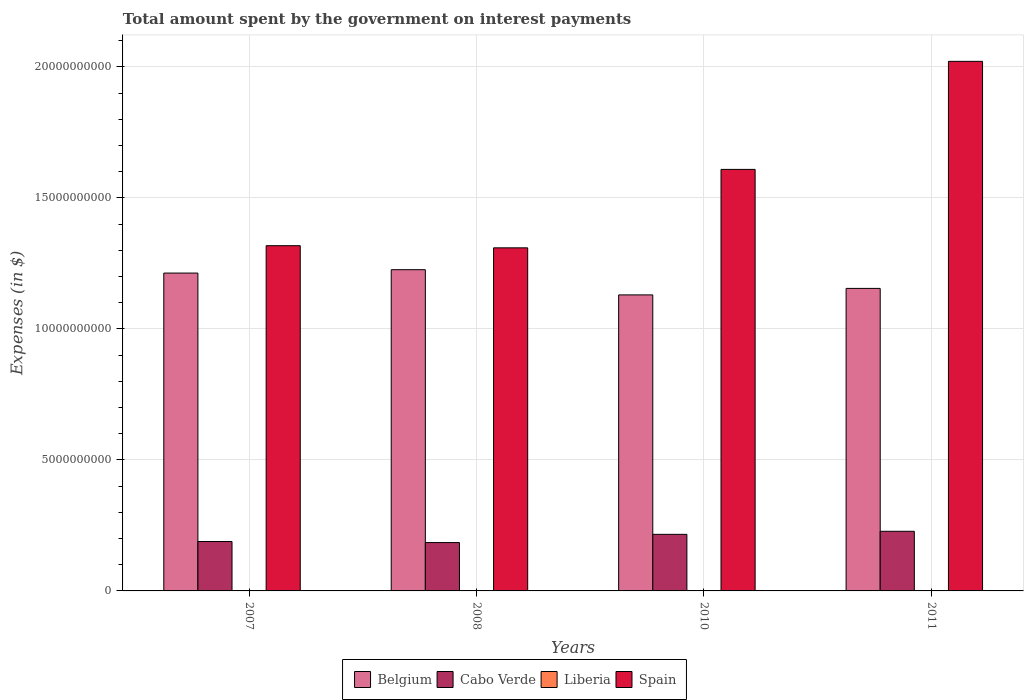Are the number of bars per tick equal to the number of legend labels?
Offer a very short reply. Yes. How many bars are there on the 4th tick from the left?
Offer a very short reply. 4. What is the label of the 3rd group of bars from the left?
Make the answer very short. 2010. What is the amount spent on interest payments by the government in Cabo Verde in 2011?
Offer a very short reply. 2.28e+09. Across all years, what is the maximum amount spent on interest payments by the government in Liberia?
Offer a terse response. 2.44e+05. Across all years, what is the minimum amount spent on interest payments by the government in Liberia?
Offer a very short reply. 2.20e+04. In which year was the amount spent on interest payments by the government in Liberia maximum?
Give a very brief answer. 2011. What is the total amount spent on interest payments by the government in Cabo Verde in the graph?
Provide a succinct answer. 8.17e+09. What is the difference between the amount spent on interest payments by the government in Belgium in 2007 and that in 2011?
Your response must be concise. 5.85e+08. What is the difference between the amount spent on interest payments by the government in Spain in 2007 and the amount spent on interest payments by the government in Belgium in 2010?
Your answer should be very brief. 1.88e+09. What is the average amount spent on interest payments by the government in Liberia per year?
Make the answer very short. 1.31e+05. In the year 2011, what is the difference between the amount spent on interest payments by the government in Belgium and amount spent on interest payments by the government in Liberia?
Offer a terse response. 1.15e+1. In how many years, is the amount spent on interest payments by the government in Liberia greater than 11000000000 $?
Ensure brevity in your answer.  0. What is the ratio of the amount spent on interest payments by the government in Cabo Verde in 2007 to that in 2010?
Give a very brief answer. 0.87. Is the difference between the amount spent on interest payments by the government in Belgium in 2007 and 2011 greater than the difference between the amount spent on interest payments by the government in Liberia in 2007 and 2011?
Provide a succinct answer. Yes. What is the difference between the highest and the second highest amount spent on interest payments by the government in Belgium?
Your answer should be compact. 1.29e+08. What is the difference between the highest and the lowest amount spent on interest payments by the government in Belgium?
Give a very brief answer. 9.62e+08. In how many years, is the amount spent on interest payments by the government in Belgium greater than the average amount spent on interest payments by the government in Belgium taken over all years?
Your answer should be compact. 2. Is the sum of the amount spent on interest payments by the government in Cabo Verde in 2008 and 2010 greater than the maximum amount spent on interest payments by the government in Liberia across all years?
Your answer should be very brief. Yes. What does the 2nd bar from the left in 2007 represents?
Keep it short and to the point. Cabo Verde. How many bars are there?
Your response must be concise. 16. How many years are there in the graph?
Give a very brief answer. 4. Are the values on the major ticks of Y-axis written in scientific E-notation?
Offer a terse response. No. Does the graph contain grids?
Your response must be concise. Yes. How are the legend labels stacked?
Your answer should be very brief. Horizontal. What is the title of the graph?
Your answer should be very brief. Total amount spent by the government on interest payments. Does "Grenada" appear as one of the legend labels in the graph?
Your response must be concise. No. What is the label or title of the Y-axis?
Make the answer very short. Expenses (in $). What is the Expenses (in $) in Belgium in 2007?
Ensure brevity in your answer.  1.21e+1. What is the Expenses (in $) in Cabo Verde in 2007?
Your response must be concise. 1.89e+09. What is the Expenses (in $) of Liberia in 2007?
Keep it short and to the point. 2.20e+04. What is the Expenses (in $) in Spain in 2007?
Your answer should be very brief. 1.32e+1. What is the Expenses (in $) of Belgium in 2008?
Offer a terse response. 1.23e+1. What is the Expenses (in $) of Cabo Verde in 2008?
Keep it short and to the point. 1.85e+09. What is the Expenses (in $) in Liberia in 2008?
Your answer should be compact. 7.01e+04. What is the Expenses (in $) in Spain in 2008?
Your answer should be compact. 1.31e+1. What is the Expenses (in $) of Belgium in 2010?
Make the answer very short. 1.13e+1. What is the Expenses (in $) of Cabo Verde in 2010?
Provide a short and direct response. 2.16e+09. What is the Expenses (in $) of Liberia in 2010?
Make the answer very short. 1.88e+05. What is the Expenses (in $) of Spain in 2010?
Provide a short and direct response. 1.61e+1. What is the Expenses (in $) of Belgium in 2011?
Offer a very short reply. 1.15e+1. What is the Expenses (in $) of Cabo Verde in 2011?
Give a very brief answer. 2.28e+09. What is the Expenses (in $) in Liberia in 2011?
Your answer should be very brief. 2.44e+05. What is the Expenses (in $) in Spain in 2011?
Give a very brief answer. 2.02e+1. Across all years, what is the maximum Expenses (in $) in Belgium?
Ensure brevity in your answer.  1.23e+1. Across all years, what is the maximum Expenses (in $) of Cabo Verde?
Keep it short and to the point. 2.28e+09. Across all years, what is the maximum Expenses (in $) of Liberia?
Provide a short and direct response. 2.44e+05. Across all years, what is the maximum Expenses (in $) of Spain?
Keep it short and to the point. 2.02e+1. Across all years, what is the minimum Expenses (in $) of Belgium?
Keep it short and to the point. 1.13e+1. Across all years, what is the minimum Expenses (in $) in Cabo Verde?
Keep it short and to the point. 1.85e+09. Across all years, what is the minimum Expenses (in $) in Liberia?
Provide a succinct answer. 2.20e+04. Across all years, what is the minimum Expenses (in $) of Spain?
Offer a terse response. 1.31e+1. What is the total Expenses (in $) in Belgium in the graph?
Your answer should be compact. 4.72e+1. What is the total Expenses (in $) in Cabo Verde in the graph?
Provide a short and direct response. 8.17e+09. What is the total Expenses (in $) in Liberia in the graph?
Ensure brevity in your answer.  5.25e+05. What is the total Expenses (in $) in Spain in the graph?
Give a very brief answer. 6.26e+1. What is the difference between the Expenses (in $) in Belgium in 2007 and that in 2008?
Your answer should be compact. -1.29e+08. What is the difference between the Expenses (in $) of Cabo Verde in 2007 and that in 2008?
Your answer should be compact. 3.98e+07. What is the difference between the Expenses (in $) in Liberia in 2007 and that in 2008?
Your answer should be compact. -4.80e+04. What is the difference between the Expenses (in $) in Spain in 2007 and that in 2008?
Offer a terse response. 8.20e+07. What is the difference between the Expenses (in $) of Belgium in 2007 and that in 2010?
Offer a terse response. 8.33e+08. What is the difference between the Expenses (in $) in Cabo Verde in 2007 and that in 2010?
Make the answer very short. -2.74e+08. What is the difference between the Expenses (in $) in Liberia in 2007 and that in 2010?
Your answer should be compact. -1.66e+05. What is the difference between the Expenses (in $) of Spain in 2007 and that in 2010?
Offer a very short reply. -2.91e+09. What is the difference between the Expenses (in $) of Belgium in 2007 and that in 2011?
Offer a very short reply. 5.85e+08. What is the difference between the Expenses (in $) of Cabo Verde in 2007 and that in 2011?
Give a very brief answer. -3.91e+08. What is the difference between the Expenses (in $) of Liberia in 2007 and that in 2011?
Keep it short and to the point. -2.22e+05. What is the difference between the Expenses (in $) in Spain in 2007 and that in 2011?
Give a very brief answer. -7.04e+09. What is the difference between the Expenses (in $) of Belgium in 2008 and that in 2010?
Keep it short and to the point. 9.62e+08. What is the difference between the Expenses (in $) in Cabo Verde in 2008 and that in 2010?
Ensure brevity in your answer.  -3.14e+08. What is the difference between the Expenses (in $) in Liberia in 2008 and that in 2010?
Offer a terse response. -1.18e+05. What is the difference between the Expenses (in $) of Spain in 2008 and that in 2010?
Give a very brief answer. -2.99e+09. What is the difference between the Expenses (in $) of Belgium in 2008 and that in 2011?
Provide a succinct answer. 7.14e+08. What is the difference between the Expenses (in $) of Cabo Verde in 2008 and that in 2011?
Keep it short and to the point. -4.31e+08. What is the difference between the Expenses (in $) of Liberia in 2008 and that in 2011?
Offer a terse response. -1.74e+05. What is the difference between the Expenses (in $) of Spain in 2008 and that in 2011?
Make the answer very short. -7.12e+09. What is the difference between the Expenses (in $) of Belgium in 2010 and that in 2011?
Offer a very short reply. -2.48e+08. What is the difference between the Expenses (in $) in Cabo Verde in 2010 and that in 2011?
Offer a terse response. -1.17e+08. What is the difference between the Expenses (in $) in Liberia in 2010 and that in 2011?
Your answer should be compact. -5.61e+04. What is the difference between the Expenses (in $) of Spain in 2010 and that in 2011?
Your answer should be compact. -4.12e+09. What is the difference between the Expenses (in $) of Belgium in 2007 and the Expenses (in $) of Cabo Verde in 2008?
Ensure brevity in your answer.  1.03e+1. What is the difference between the Expenses (in $) of Belgium in 2007 and the Expenses (in $) of Liberia in 2008?
Your answer should be compact. 1.21e+1. What is the difference between the Expenses (in $) of Belgium in 2007 and the Expenses (in $) of Spain in 2008?
Ensure brevity in your answer.  -9.63e+08. What is the difference between the Expenses (in $) in Cabo Verde in 2007 and the Expenses (in $) in Liberia in 2008?
Give a very brief answer. 1.89e+09. What is the difference between the Expenses (in $) in Cabo Verde in 2007 and the Expenses (in $) in Spain in 2008?
Give a very brief answer. -1.12e+1. What is the difference between the Expenses (in $) of Liberia in 2007 and the Expenses (in $) of Spain in 2008?
Ensure brevity in your answer.  -1.31e+1. What is the difference between the Expenses (in $) in Belgium in 2007 and the Expenses (in $) in Cabo Verde in 2010?
Offer a terse response. 9.97e+09. What is the difference between the Expenses (in $) in Belgium in 2007 and the Expenses (in $) in Liberia in 2010?
Your answer should be compact. 1.21e+1. What is the difference between the Expenses (in $) in Belgium in 2007 and the Expenses (in $) in Spain in 2010?
Ensure brevity in your answer.  -3.96e+09. What is the difference between the Expenses (in $) in Cabo Verde in 2007 and the Expenses (in $) in Liberia in 2010?
Keep it short and to the point. 1.89e+09. What is the difference between the Expenses (in $) of Cabo Verde in 2007 and the Expenses (in $) of Spain in 2010?
Offer a very short reply. -1.42e+1. What is the difference between the Expenses (in $) in Liberia in 2007 and the Expenses (in $) in Spain in 2010?
Give a very brief answer. -1.61e+1. What is the difference between the Expenses (in $) in Belgium in 2007 and the Expenses (in $) in Cabo Verde in 2011?
Offer a terse response. 9.86e+09. What is the difference between the Expenses (in $) in Belgium in 2007 and the Expenses (in $) in Liberia in 2011?
Your answer should be very brief. 1.21e+1. What is the difference between the Expenses (in $) of Belgium in 2007 and the Expenses (in $) of Spain in 2011?
Offer a terse response. -8.08e+09. What is the difference between the Expenses (in $) in Cabo Verde in 2007 and the Expenses (in $) in Liberia in 2011?
Your answer should be very brief. 1.89e+09. What is the difference between the Expenses (in $) in Cabo Verde in 2007 and the Expenses (in $) in Spain in 2011?
Keep it short and to the point. -1.83e+1. What is the difference between the Expenses (in $) in Liberia in 2007 and the Expenses (in $) in Spain in 2011?
Offer a terse response. -2.02e+1. What is the difference between the Expenses (in $) in Belgium in 2008 and the Expenses (in $) in Cabo Verde in 2010?
Offer a very short reply. 1.01e+1. What is the difference between the Expenses (in $) in Belgium in 2008 and the Expenses (in $) in Liberia in 2010?
Provide a succinct answer. 1.23e+1. What is the difference between the Expenses (in $) in Belgium in 2008 and the Expenses (in $) in Spain in 2010?
Ensure brevity in your answer.  -3.83e+09. What is the difference between the Expenses (in $) of Cabo Verde in 2008 and the Expenses (in $) of Liberia in 2010?
Give a very brief answer. 1.85e+09. What is the difference between the Expenses (in $) in Cabo Verde in 2008 and the Expenses (in $) in Spain in 2010?
Your response must be concise. -1.42e+1. What is the difference between the Expenses (in $) of Liberia in 2008 and the Expenses (in $) of Spain in 2010?
Your answer should be compact. -1.61e+1. What is the difference between the Expenses (in $) of Belgium in 2008 and the Expenses (in $) of Cabo Verde in 2011?
Your answer should be compact. 9.98e+09. What is the difference between the Expenses (in $) in Belgium in 2008 and the Expenses (in $) in Liberia in 2011?
Keep it short and to the point. 1.23e+1. What is the difference between the Expenses (in $) of Belgium in 2008 and the Expenses (in $) of Spain in 2011?
Give a very brief answer. -7.95e+09. What is the difference between the Expenses (in $) of Cabo Verde in 2008 and the Expenses (in $) of Liberia in 2011?
Your answer should be very brief. 1.85e+09. What is the difference between the Expenses (in $) of Cabo Verde in 2008 and the Expenses (in $) of Spain in 2011?
Provide a short and direct response. -1.84e+1. What is the difference between the Expenses (in $) in Liberia in 2008 and the Expenses (in $) in Spain in 2011?
Make the answer very short. -2.02e+1. What is the difference between the Expenses (in $) in Belgium in 2010 and the Expenses (in $) in Cabo Verde in 2011?
Your response must be concise. 9.02e+09. What is the difference between the Expenses (in $) of Belgium in 2010 and the Expenses (in $) of Liberia in 2011?
Your answer should be compact. 1.13e+1. What is the difference between the Expenses (in $) in Belgium in 2010 and the Expenses (in $) in Spain in 2011?
Your answer should be very brief. -8.91e+09. What is the difference between the Expenses (in $) of Cabo Verde in 2010 and the Expenses (in $) of Liberia in 2011?
Your answer should be compact. 2.16e+09. What is the difference between the Expenses (in $) in Cabo Verde in 2010 and the Expenses (in $) in Spain in 2011?
Your response must be concise. -1.81e+1. What is the difference between the Expenses (in $) in Liberia in 2010 and the Expenses (in $) in Spain in 2011?
Offer a terse response. -2.02e+1. What is the average Expenses (in $) in Belgium per year?
Your answer should be very brief. 1.18e+1. What is the average Expenses (in $) of Cabo Verde per year?
Offer a terse response. 2.04e+09. What is the average Expenses (in $) of Liberia per year?
Provide a short and direct response. 1.31e+05. What is the average Expenses (in $) in Spain per year?
Provide a short and direct response. 1.56e+1. In the year 2007, what is the difference between the Expenses (in $) in Belgium and Expenses (in $) in Cabo Verde?
Your answer should be very brief. 1.02e+1. In the year 2007, what is the difference between the Expenses (in $) in Belgium and Expenses (in $) in Liberia?
Your response must be concise. 1.21e+1. In the year 2007, what is the difference between the Expenses (in $) of Belgium and Expenses (in $) of Spain?
Offer a terse response. -1.04e+09. In the year 2007, what is the difference between the Expenses (in $) in Cabo Verde and Expenses (in $) in Liberia?
Provide a short and direct response. 1.89e+09. In the year 2007, what is the difference between the Expenses (in $) in Cabo Verde and Expenses (in $) in Spain?
Keep it short and to the point. -1.13e+1. In the year 2007, what is the difference between the Expenses (in $) in Liberia and Expenses (in $) in Spain?
Provide a succinct answer. -1.32e+1. In the year 2008, what is the difference between the Expenses (in $) of Belgium and Expenses (in $) of Cabo Verde?
Ensure brevity in your answer.  1.04e+1. In the year 2008, what is the difference between the Expenses (in $) in Belgium and Expenses (in $) in Liberia?
Offer a very short reply. 1.23e+1. In the year 2008, what is the difference between the Expenses (in $) in Belgium and Expenses (in $) in Spain?
Give a very brief answer. -8.34e+08. In the year 2008, what is the difference between the Expenses (in $) of Cabo Verde and Expenses (in $) of Liberia?
Your answer should be compact. 1.85e+09. In the year 2008, what is the difference between the Expenses (in $) in Cabo Verde and Expenses (in $) in Spain?
Ensure brevity in your answer.  -1.12e+1. In the year 2008, what is the difference between the Expenses (in $) of Liberia and Expenses (in $) of Spain?
Your answer should be compact. -1.31e+1. In the year 2010, what is the difference between the Expenses (in $) in Belgium and Expenses (in $) in Cabo Verde?
Give a very brief answer. 9.14e+09. In the year 2010, what is the difference between the Expenses (in $) of Belgium and Expenses (in $) of Liberia?
Your answer should be very brief. 1.13e+1. In the year 2010, what is the difference between the Expenses (in $) of Belgium and Expenses (in $) of Spain?
Ensure brevity in your answer.  -4.79e+09. In the year 2010, what is the difference between the Expenses (in $) of Cabo Verde and Expenses (in $) of Liberia?
Your response must be concise. 2.16e+09. In the year 2010, what is the difference between the Expenses (in $) of Cabo Verde and Expenses (in $) of Spain?
Provide a short and direct response. -1.39e+1. In the year 2010, what is the difference between the Expenses (in $) in Liberia and Expenses (in $) in Spain?
Offer a terse response. -1.61e+1. In the year 2011, what is the difference between the Expenses (in $) of Belgium and Expenses (in $) of Cabo Verde?
Offer a very short reply. 9.27e+09. In the year 2011, what is the difference between the Expenses (in $) in Belgium and Expenses (in $) in Liberia?
Keep it short and to the point. 1.15e+1. In the year 2011, what is the difference between the Expenses (in $) of Belgium and Expenses (in $) of Spain?
Give a very brief answer. -8.67e+09. In the year 2011, what is the difference between the Expenses (in $) of Cabo Verde and Expenses (in $) of Liberia?
Your answer should be compact. 2.28e+09. In the year 2011, what is the difference between the Expenses (in $) in Cabo Verde and Expenses (in $) in Spain?
Give a very brief answer. -1.79e+1. In the year 2011, what is the difference between the Expenses (in $) of Liberia and Expenses (in $) of Spain?
Give a very brief answer. -2.02e+1. What is the ratio of the Expenses (in $) in Cabo Verde in 2007 to that in 2008?
Your response must be concise. 1.02. What is the ratio of the Expenses (in $) of Liberia in 2007 to that in 2008?
Make the answer very short. 0.31. What is the ratio of the Expenses (in $) of Spain in 2007 to that in 2008?
Your answer should be very brief. 1.01. What is the ratio of the Expenses (in $) of Belgium in 2007 to that in 2010?
Your response must be concise. 1.07. What is the ratio of the Expenses (in $) in Cabo Verde in 2007 to that in 2010?
Offer a very short reply. 0.87. What is the ratio of the Expenses (in $) in Liberia in 2007 to that in 2010?
Provide a succinct answer. 0.12. What is the ratio of the Expenses (in $) of Spain in 2007 to that in 2010?
Your answer should be very brief. 0.82. What is the ratio of the Expenses (in $) in Belgium in 2007 to that in 2011?
Your answer should be very brief. 1.05. What is the ratio of the Expenses (in $) of Cabo Verde in 2007 to that in 2011?
Make the answer very short. 0.83. What is the ratio of the Expenses (in $) in Liberia in 2007 to that in 2011?
Offer a very short reply. 0.09. What is the ratio of the Expenses (in $) of Spain in 2007 to that in 2011?
Keep it short and to the point. 0.65. What is the ratio of the Expenses (in $) in Belgium in 2008 to that in 2010?
Your response must be concise. 1.09. What is the ratio of the Expenses (in $) of Cabo Verde in 2008 to that in 2010?
Your answer should be very brief. 0.85. What is the ratio of the Expenses (in $) of Liberia in 2008 to that in 2010?
Ensure brevity in your answer.  0.37. What is the ratio of the Expenses (in $) in Spain in 2008 to that in 2010?
Keep it short and to the point. 0.81. What is the ratio of the Expenses (in $) of Belgium in 2008 to that in 2011?
Provide a succinct answer. 1.06. What is the ratio of the Expenses (in $) of Cabo Verde in 2008 to that in 2011?
Provide a short and direct response. 0.81. What is the ratio of the Expenses (in $) in Liberia in 2008 to that in 2011?
Ensure brevity in your answer.  0.29. What is the ratio of the Expenses (in $) in Spain in 2008 to that in 2011?
Your answer should be very brief. 0.65. What is the ratio of the Expenses (in $) of Belgium in 2010 to that in 2011?
Your answer should be very brief. 0.98. What is the ratio of the Expenses (in $) of Cabo Verde in 2010 to that in 2011?
Keep it short and to the point. 0.95. What is the ratio of the Expenses (in $) in Liberia in 2010 to that in 2011?
Give a very brief answer. 0.77. What is the ratio of the Expenses (in $) of Spain in 2010 to that in 2011?
Provide a short and direct response. 0.8. What is the difference between the highest and the second highest Expenses (in $) of Belgium?
Offer a very short reply. 1.29e+08. What is the difference between the highest and the second highest Expenses (in $) in Cabo Verde?
Make the answer very short. 1.17e+08. What is the difference between the highest and the second highest Expenses (in $) of Liberia?
Offer a very short reply. 5.61e+04. What is the difference between the highest and the second highest Expenses (in $) in Spain?
Make the answer very short. 4.12e+09. What is the difference between the highest and the lowest Expenses (in $) of Belgium?
Ensure brevity in your answer.  9.62e+08. What is the difference between the highest and the lowest Expenses (in $) of Cabo Verde?
Give a very brief answer. 4.31e+08. What is the difference between the highest and the lowest Expenses (in $) of Liberia?
Make the answer very short. 2.22e+05. What is the difference between the highest and the lowest Expenses (in $) in Spain?
Give a very brief answer. 7.12e+09. 